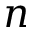Convert formula to latex. <formula><loc_0><loc_0><loc_500><loc_500>n</formula> 